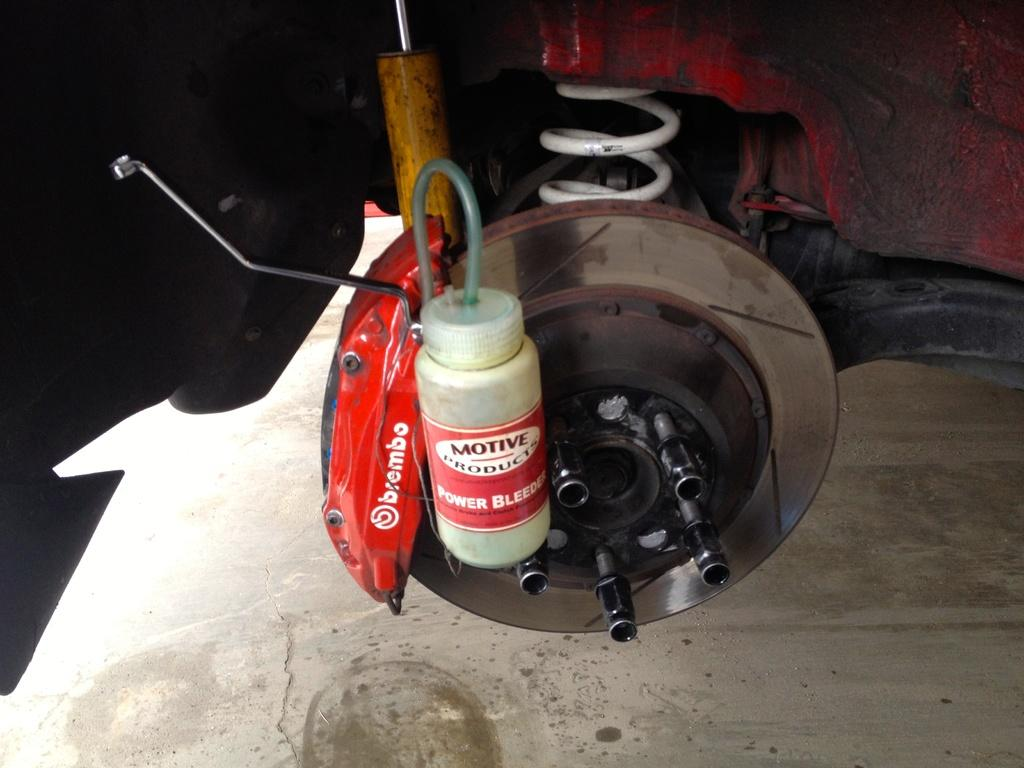What is attached to the wheel alloy in the image? There is a bottle attached to a wheel alloy in the image. What other object can be seen in the image? There is a spring in the image. What is visible beneath the objects in the image? The ground is visible in the image. What language is spoken by the bird in the image? There is no bird present in the image, so it is not possible to determine what language might be spoken. 